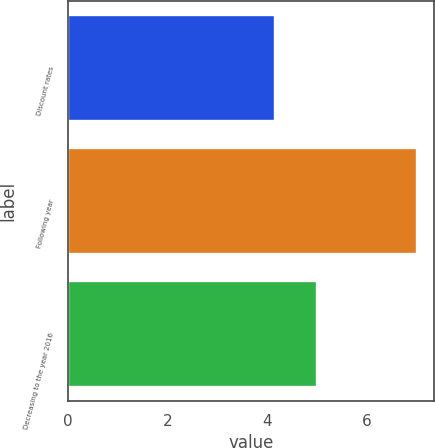Convert chart to OTSL. <chart><loc_0><loc_0><loc_500><loc_500><bar_chart><fcel>Discount rates<fcel>Following year<fcel>Decreasing to the year 2016<nl><fcel>4.15<fcel>7<fcel>5<nl></chart> 